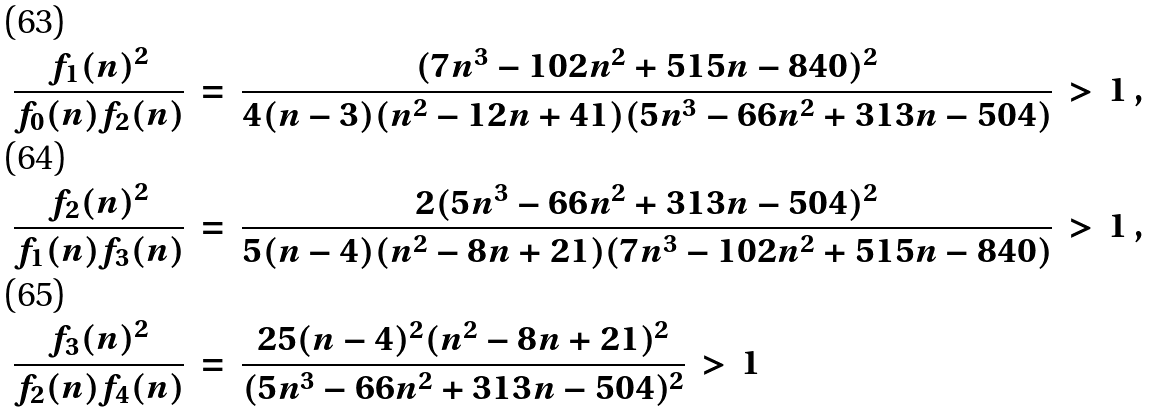Convert formula to latex. <formula><loc_0><loc_0><loc_500><loc_500>\frac { f _ { 1 } ( n ) ^ { 2 } } { f _ { 0 } ( n ) f _ { 2 } ( n ) } \, & = \, \frac { ( 7 n ^ { 3 } - 1 0 2 n ^ { 2 } + 5 1 5 n - 8 4 0 ) ^ { 2 } } { 4 ( n - 3 ) ( n ^ { 2 } - 1 2 n + 4 1 ) ( 5 n ^ { 3 } - 6 6 n ^ { 2 } + 3 1 3 n - 5 0 4 ) } \, > \, 1 \, , \\ \frac { f _ { 2 } ( n ) ^ { 2 } } { f _ { 1 } ( n ) f _ { 3 } ( n ) } \, & = \, \frac { 2 ( 5 n ^ { 3 } - 6 6 n ^ { 2 } + 3 1 3 n - 5 0 4 ) ^ { 2 } } { 5 ( n - 4 ) ( n ^ { 2 } - 8 n + 2 1 ) ( 7 n ^ { 3 } - 1 0 2 n ^ { 2 } + 5 1 5 n - 8 4 0 ) } \, > \, 1 \, , \\ \frac { f _ { 3 } ( n ) ^ { 2 } } { f _ { 2 } ( n ) f _ { 4 } ( n ) } \, & = \, \frac { 2 5 ( n - 4 ) ^ { 2 } ( n ^ { 2 } - 8 n + 2 1 ) ^ { 2 } } { ( 5 n ^ { 3 } - 6 6 n ^ { 2 } + 3 1 3 n - 5 0 4 ) ^ { 2 } } \, > \, 1</formula> 